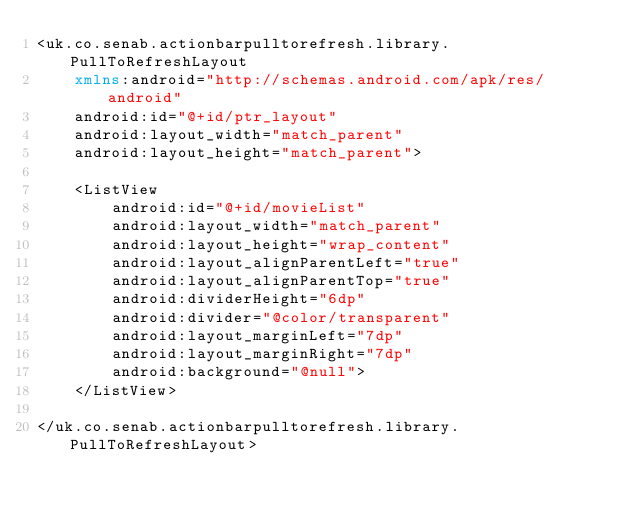<code> <loc_0><loc_0><loc_500><loc_500><_XML_><uk.co.senab.actionbarpulltorefresh.library.PullToRefreshLayout
    xmlns:android="http://schemas.android.com/apk/res/android"
    android:id="@+id/ptr_layout"
    android:layout_width="match_parent"
    android:layout_height="match_parent">

    <ListView
        android:id="@+id/movieList"
        android:layout_width="match_parent"
        android:layout_height="wrap_content"
        android:layout_alignParentLeft="true"
        android:layout_alignParentTop="true"
        android:dividerHeight="6dp"
        android:divider="@color/transparent"
        android:layout_marginLeft="7dp"
        android:layout_marginRight="7dp"
        android:background="@null">
    </ListView>

</uk.co.senab.actionbarpulltorefresh.library.PullToRefreshLayout>

</code> 